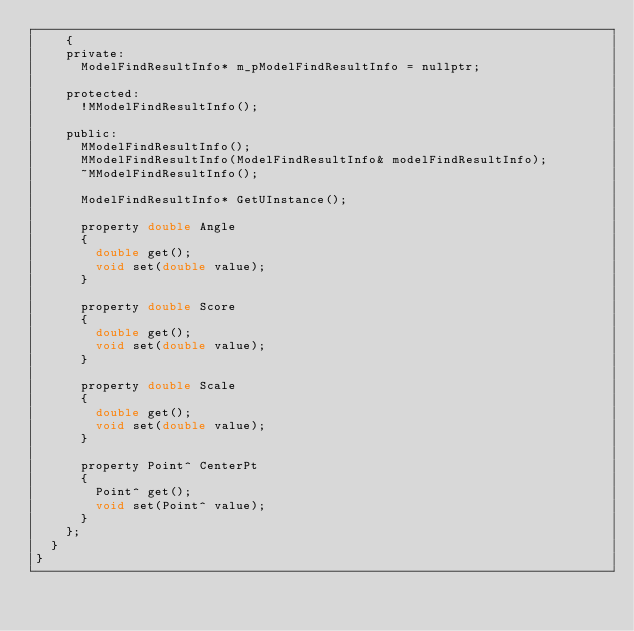<code> <loc_0><loc_0><loc_500><loc_500><_C_>		{
		private:
			ModelFindResultInfo* m_pModelFindResultInfo = nullptr;

		protected:
			!MModelFindResultInfo();

		public:
			MModelFindResultInfo();
			MModelFindResultInfo(ModelFindResultInfo& modelFindResultInfo);
			~MModelFindResultInfo();

			ModelFindResultInfo* GetUInstance();

			property double Angle
			{
				double get();
				void set(double value);
			}

			property double Score
			{
				double get();
				void set(double value);
			}

			property double Scale
			{
				double get();
				void set(double value);
			}

			property Point^ CenterPt
			{
				Point^ get();
				void set(Point^ value);
			}
		};
	}
}
</code> 